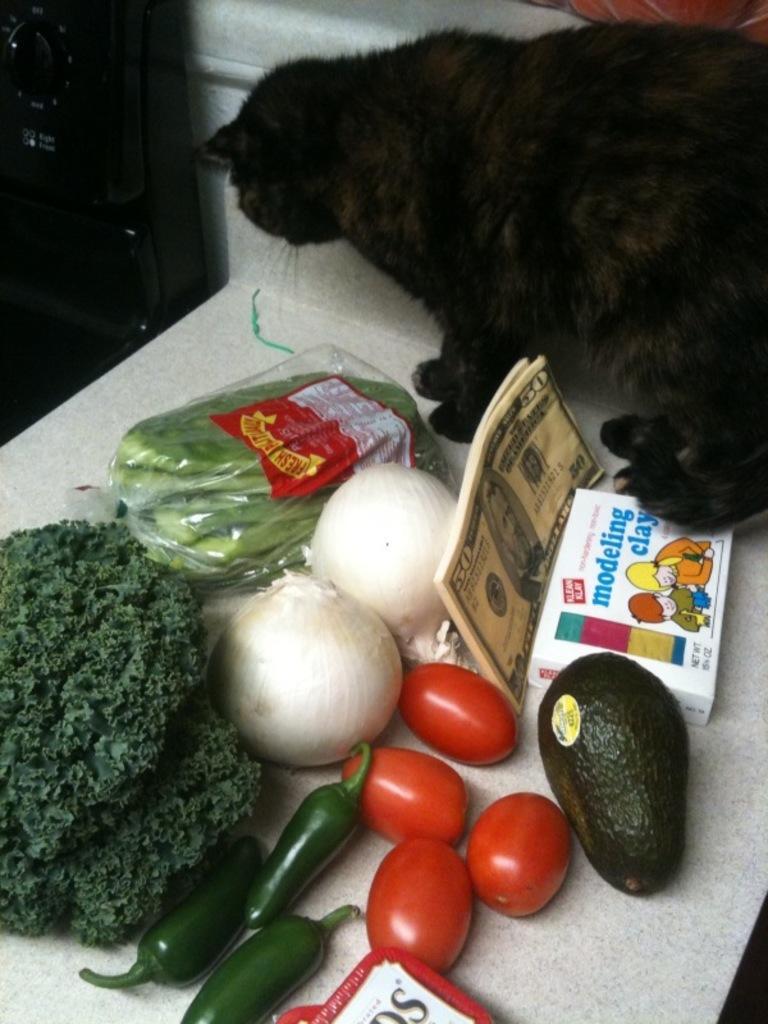Describe this image in one or two sentences. In this image we can see some vegetables like onions, tomatoes, green chilies, broccoli, avocado and some beans in a cover which are placed on a table. We can also see some notes, a box and a cat beside them. At the top left we can see a device. 